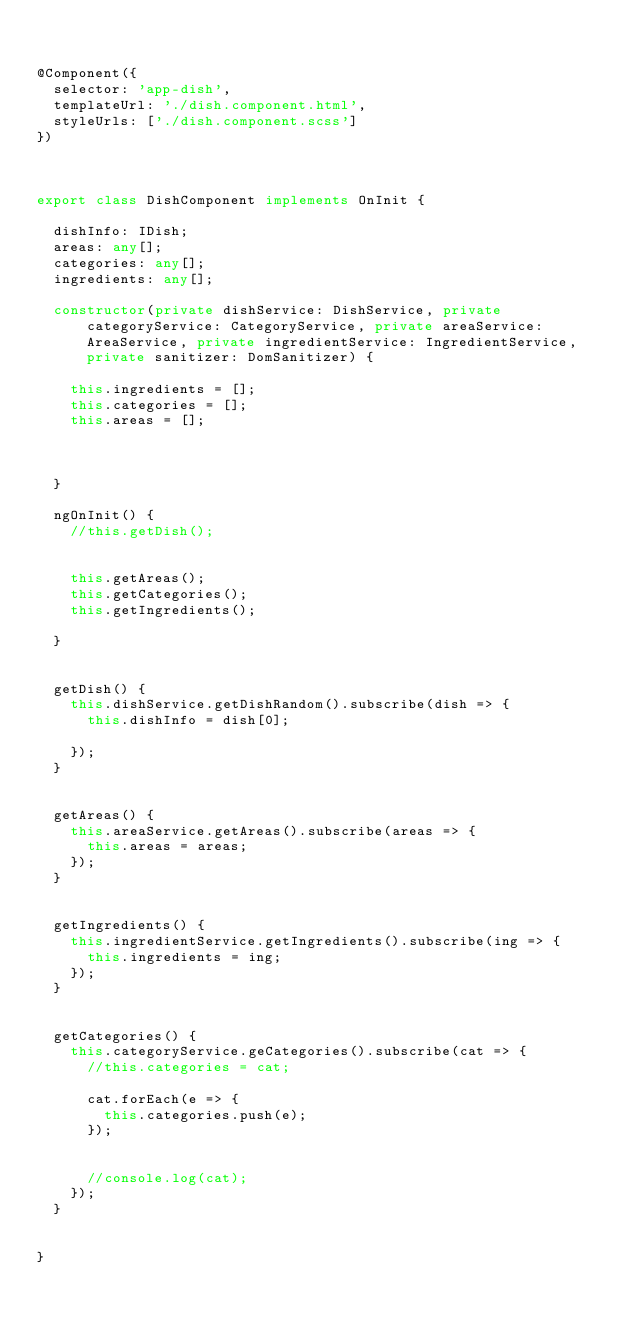Convert code to text. <code><loc_0><loc_0><loc_500><loc_500><_TypeScript_>

@Component({
  selector: 'app-dish',
  templateUrl: './dish.component.html',
  styleUrls: ['./dish.component.scss']
})



export class DishComponent implements OnInit {

  dishInfo: IDish;
  areas: any[];
  categories: any[];
  ingredients: any[];

  constructor(private dishService: DishService, private categoryService: CategoryService, private areaService: AreaService, private ingredientService: IngredientService, private sanitizer: DomSanitizer) {

    this.ingredients = [];
    this.categories = [];
    this.areas = [];



  }

  ngOnInit() {
    //this.getDish();


    this.getAreas();
    this.getCategories();
    this.getIngredients();

  }


  getDish() {
    this.dishService.getDishRandom().subscribe(dish => {
      this.dishInfo = dish[0];

    });
  }


  getAreas() {
    this.areaService.getAreas().subscribe(areas => {
      this.areas = areas;
    });
  }


  getIngredients() {
    this.ingredientService.getIngredients().subscribe(ing => {
      this.ingredients = ing;
    });
  }


  getCategories() {
    this.categoryService.geCategories().subscribe(cat => {
      //this.categories = cat;

      cat.forEach(e => {
        this.categories.push(e);
      });


      //console.log(cat);
    });
  }


}
</code> 